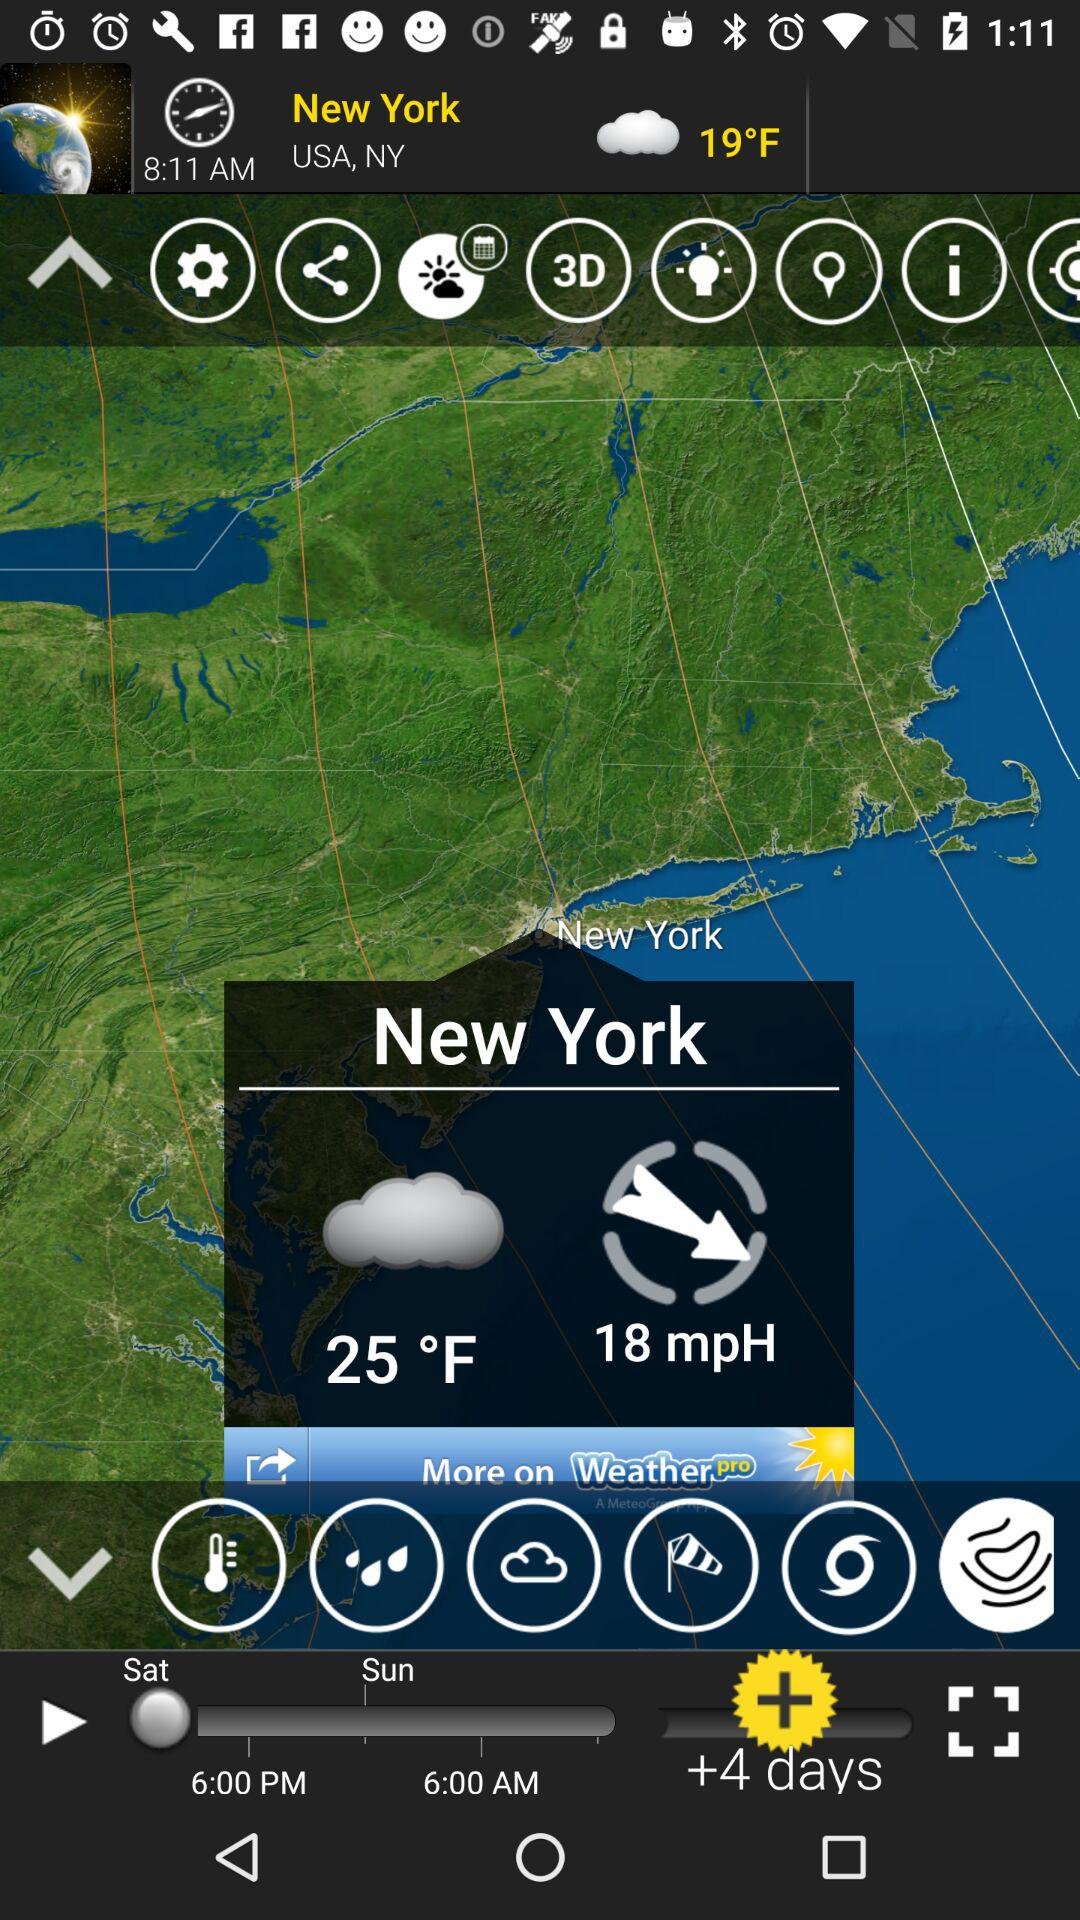How many extra days have been added? The extra days that have been added are 4. 